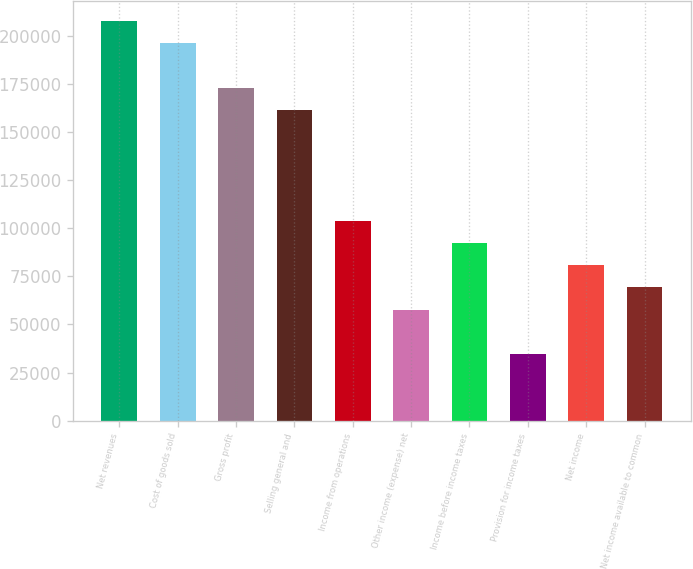Convert chart to OTSL. <chart><loc_0><loc_0><loc_500><loc_500><bar_chart><fcel>Net revenues<fcel>Cost of goods sold<fcel>Gross profit<fcel>Selling general and<fcel>Income from operations<fcel>Other income (expense) net<fcel>Income before income taxes<fcel>Provision for income taxes<fcel>Net income<fcel>Net income available to common<nl><fcel>207754<fcel>196212<fcel>173128<fcel>161587<fcel>103877<fcel>57709.6<fcel>92335.3<fcel>34625.8<fcel>80793.4<fcel>69251.5<nl></chart> 